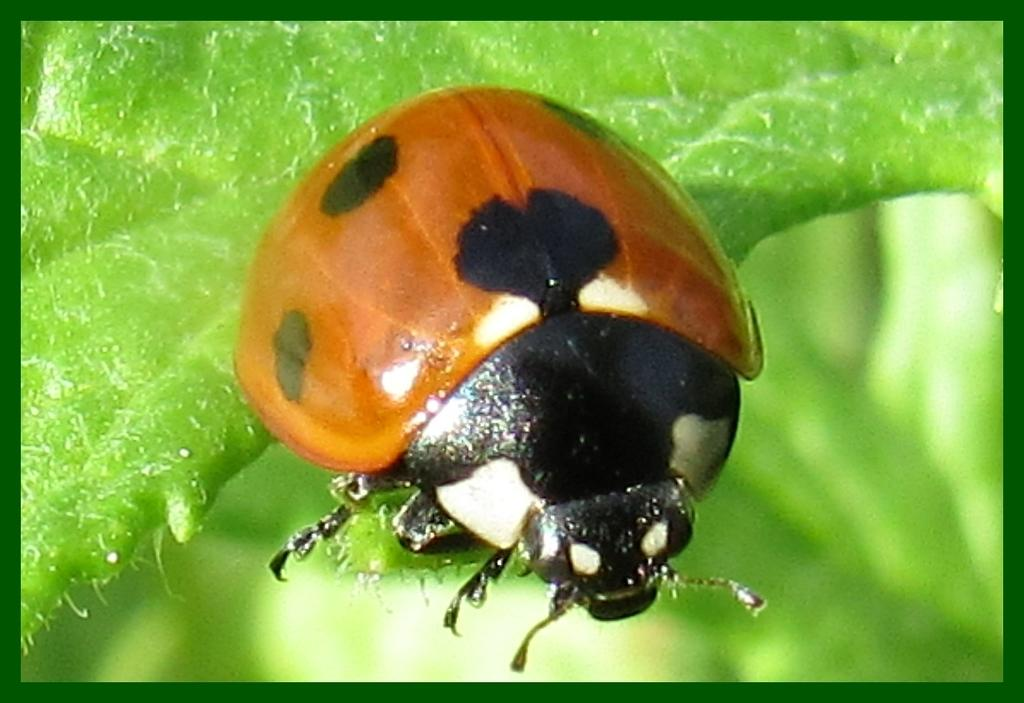What is present on the leaf in the image? There is a bug on the leaf in the image. Can you describe the location of the bug in the image? The bug is on a leaf in the image. What type of learning does the bug exhibit in the image? The image does not provide information about the bug's learning abilities. 